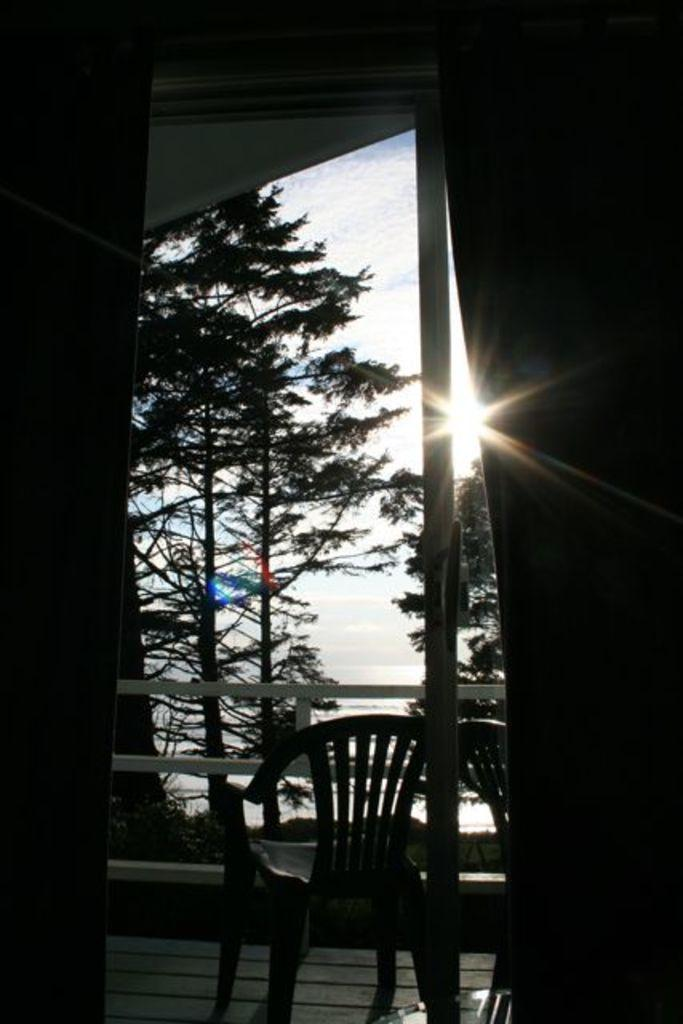What type of furniture is present in the image? There are chairs in the image. What type of natural elements can be seen in the image? There are trees in the image. What celestial body is visible in the image? The sun is visible in the image. What part of the natural environment is visible in the image? The sky is visible in the image. What type of watch is visible on the tree in the image? There is no watch present in the image; it features chairs, trees, the sun, and the sky. Can you tell me what time the clock in the image is showing? There is no clock present in the image. 